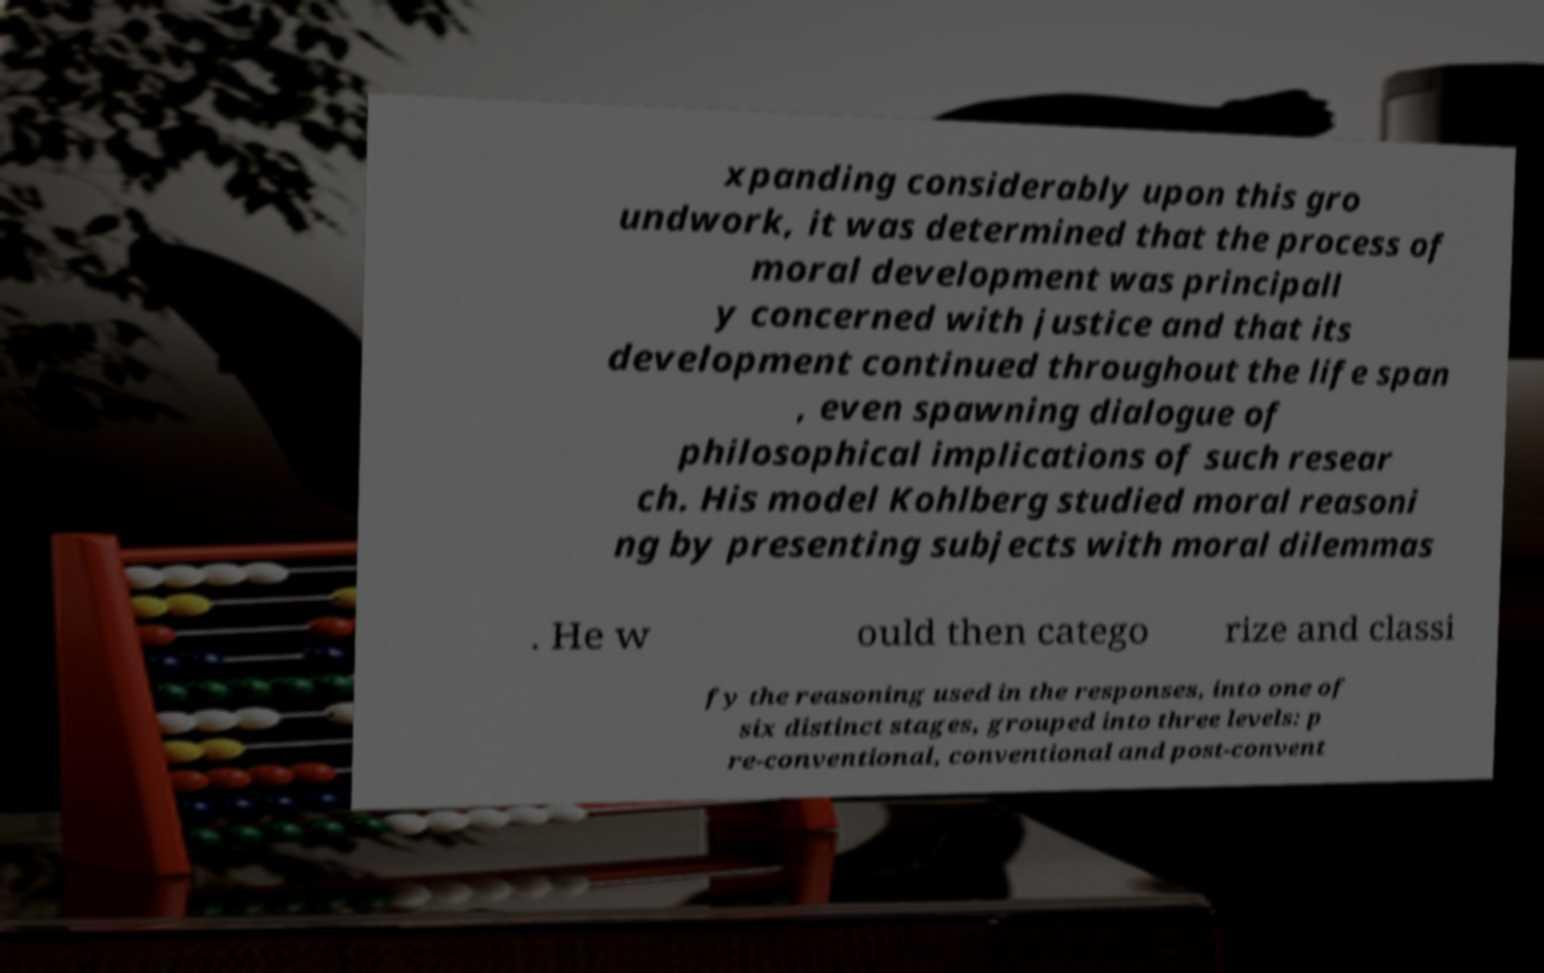Please identify and transcribe the text found in this image. xpanding considerably upon this gro undwork, it was determined that the process of moral development was principall y concerned with justice and that its development continued throughout the life span , even spawning dialogue of philosophical implications of such resear ch. His model Kohlberg studied moral reasoni ng by presenting subjects with moral dilemmas . He w ould then catego rize and classi fy the reasoning used in the responses, into one of six distinct stages, grouped into three levels: p re-conventional, conventional and post-convent 